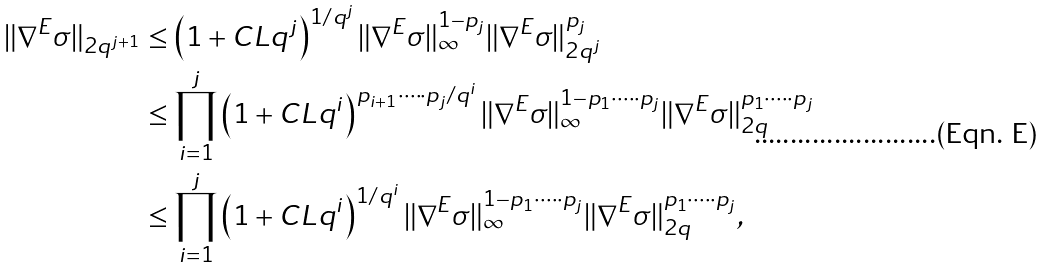<formula> <loc_0><loc_0><loc_500><loc_500>\| \nabla ^ { E } \sigma \| _ { 2 q ^ { j + 1 } } & \leq \left ( 1 + C L q ^ { j } \right ) ^ { 1 / q ^ { j } } \| \nabla ^ { E } \sigma \| _ { \infty } ^ { 1 - p _ { j } } \| \nabla ^ { E } \sigma \| _ { 2 q ^ { j } } ^ { p _ { j } } \\ & \leq \prod _ { i = 1 } ^ { j } \left ( 1 + C L q ^ { i } \right ) ^ { p _ { i + 1 } \cdot \dots \cdot p _ { j } / q ^ { i } } \| \nabla ^ { E } \sigma \| _ { \infty } ^ { 1 - p _ { 1 } \cdot \dots \cdot p _ { j } } \| \nabla ^ { E } \sigma \| _ { 2 q } ^ { p _ { 1 } \cdot \dots \cdot p _ { j } } \\ & \leq \prod _ { i = 1 } ^ { j } \left ( 1 + C L q ^ { i } \right ) ^ { 1 / q ^ { i } } \| \nabla ^ { E } \sigma \| _ { \infty } ^ { 1 - p _ { 1 } \cdot \dots \cdot p _ { j } } \| \nabla ^ { E } \sigma \| _ { 2 q } ^ { p _ { 1 } \cdot \dots \cdot p _ { j } } ,</formula> 